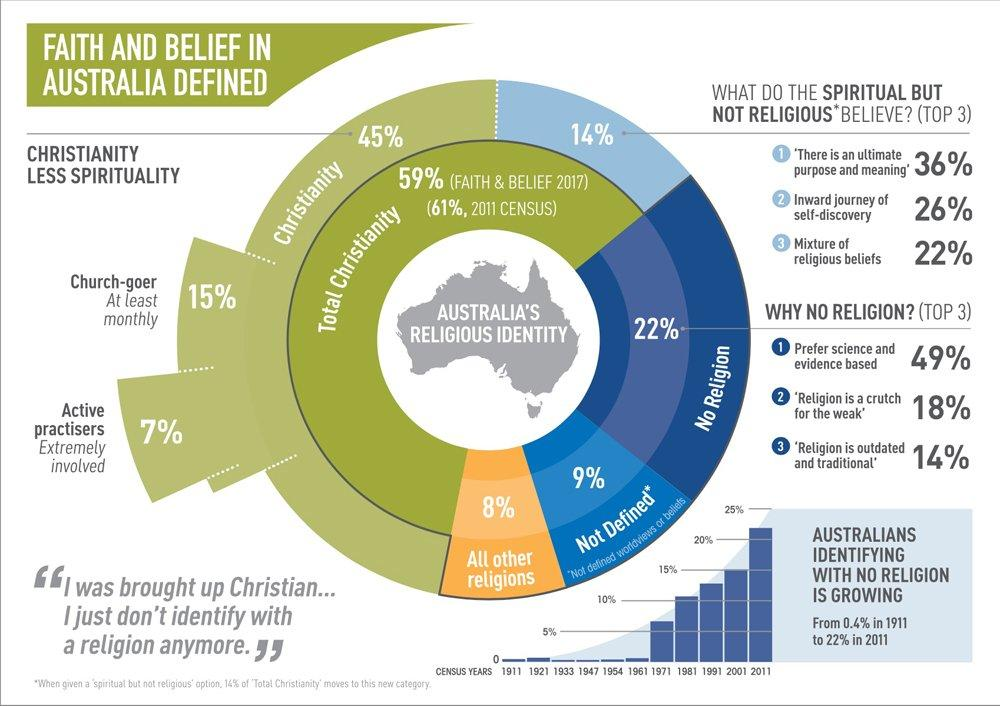Draw attention to some important aspects in this diagram. In total, approximately 22% of the population are church-goers and active practitioners. Out of all religions and religions not defined, 17% belong to other religions and religions not defined. Religion is viewed as a crutch for the weak due to the second reason for not following any religion. In 2001, the percentage was approximately 15%. The religion with the most number of followers is Christianity. 